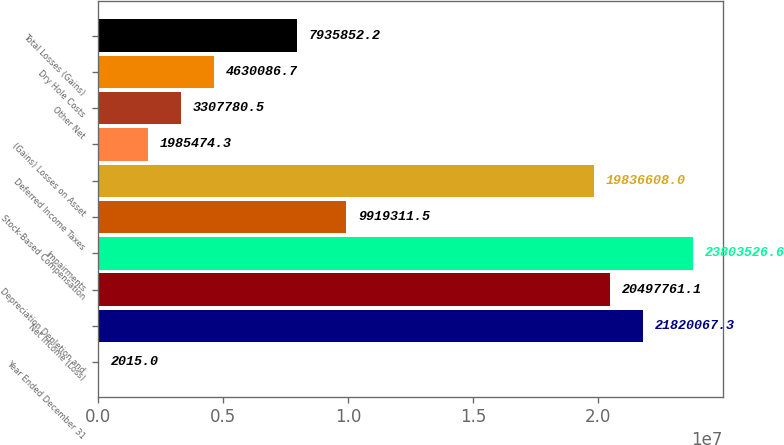Convert chart. <chart><loc_0><loc_0><loc_500><loc_500><bar_chart><fcel>Year Ended December 31<fcel>Net Income (Loss)<fcel>Depreciation Depletion and<fcel>Impairments<fcel>Stock-Based Compensation<fcel>Deferred Income Taxes<fcel>(Gains) Losses on Asset<fcel>Other Net<fcel>Dry Hole Costs<fcel>Total Losses (Gains)<nl><fcel>2015<fcel>2.18201e+07<fcel>2.04978e+07<fcel>2.38035e+07<fcel>9.91931e+06<fcel>1.98366e+07<fcel>1.98547e+06<fcel>3.30778e+06<fcel>4.63009e+06<fcel>7.93585e+06<nl></chart> 